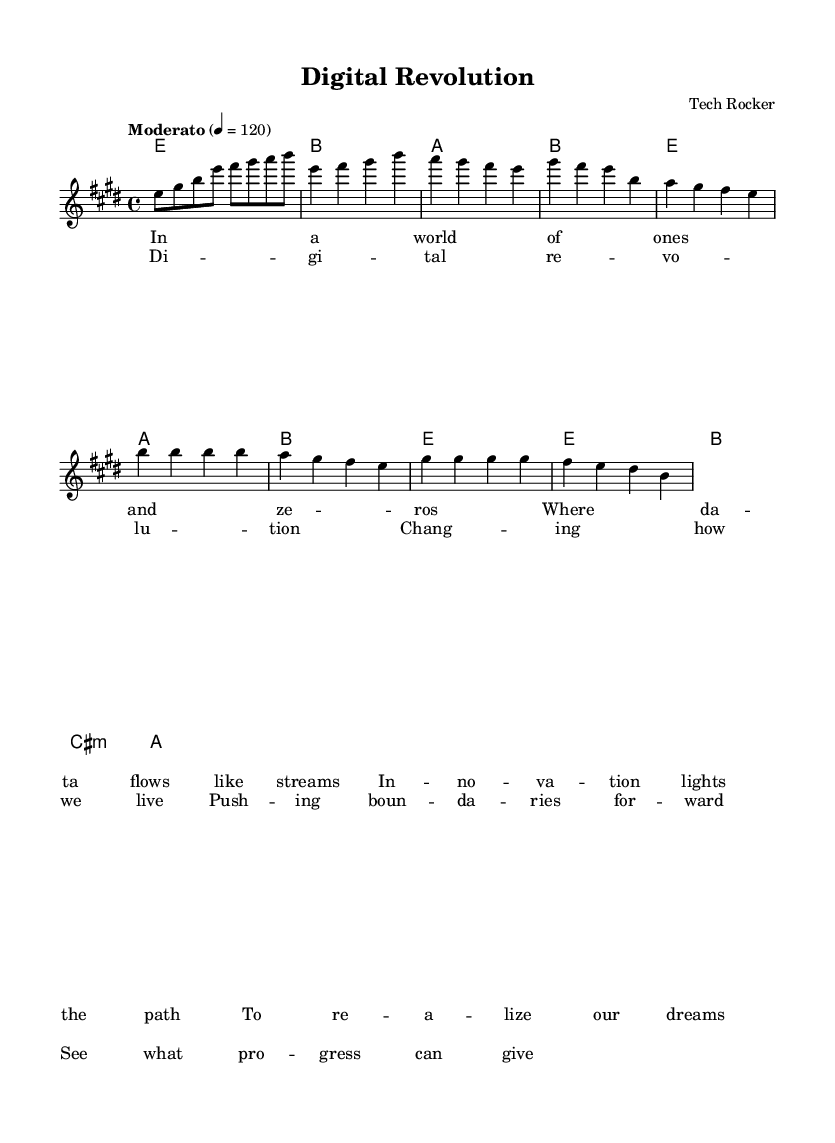What is the key signature of this music? The key signature is indicated at the beginning of the score with a sharp on F and C, which identifies it as E major.
Answer: E major What is the time signature of this music? The time signature is found at the start of the music, represented as a fraction with a 4 on top and a 4 on the bottom, indicating four beats in a measure and each beat being a quarter note.
Answer: 4/4 What is the tempo marking for this piece? The tempo is specified as "Moderato" with a metronome marking of 4 equals 120, indicating the pace of the music.
Answer: Moderato, 4 = 120 How many measures are there in the chorus section? The chorus section can be counted by analyzing the notation and confirming the structure, which has four measures in total.
Answer: 4 What is the last chord played in the piece? The last chord can be identified from the harmony section, which shows the final harmony symbol indicating an A major chord being played at the end.
Answer: A How many lines of lyrics are present in the verse? The verse section consists of four distinct lines of lyrics, which can be counted directly from the lyric representation in the sheet music.
Answer: 4 What type of musical mode is used for the harmony? By looking at the chord symbols in the harmony section, they represent a common chord mode used in popular music, which is a major chord mode.
Answer: Major 